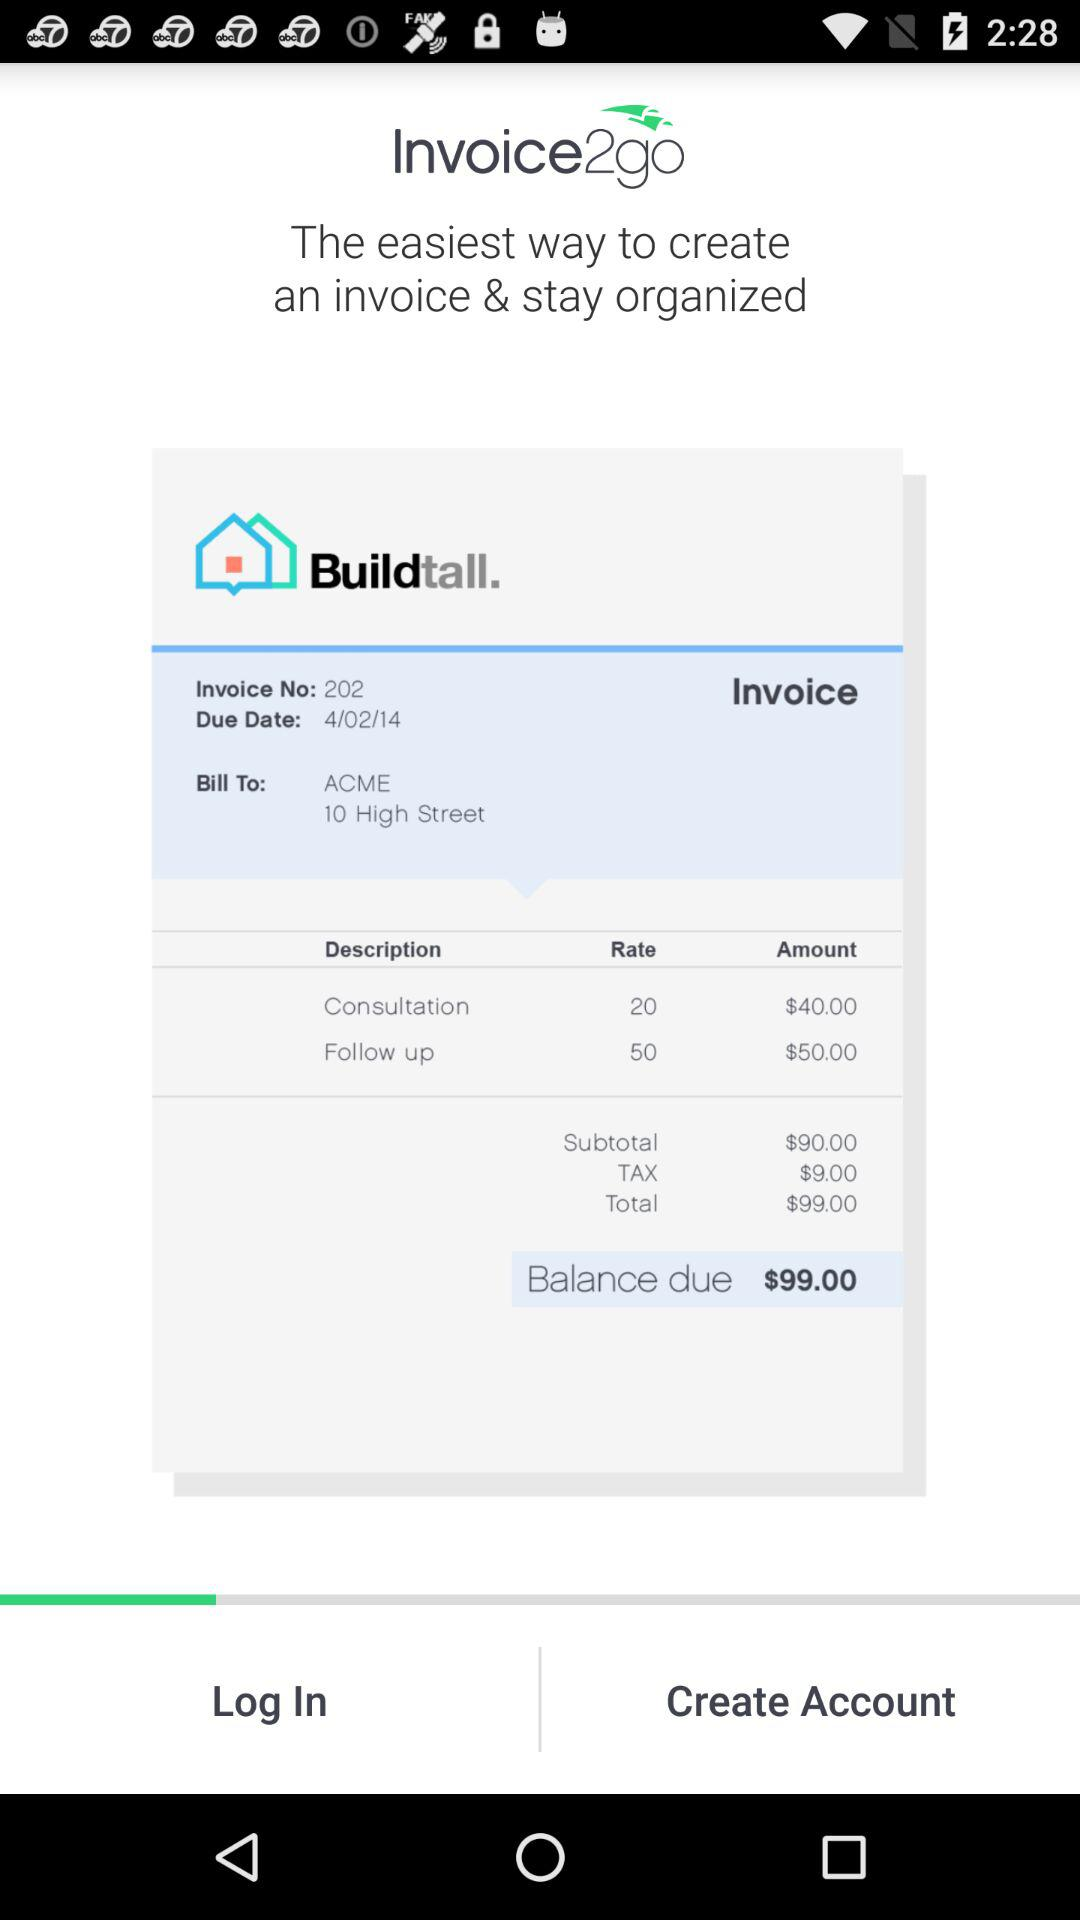What is the application name? The application name is "Invoice2go". 